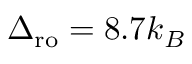<formula> <loc_0><loc_0><loc_500><loc_500>\Delta _ { r o } = 8 . 7 k _ { B }</formula> 